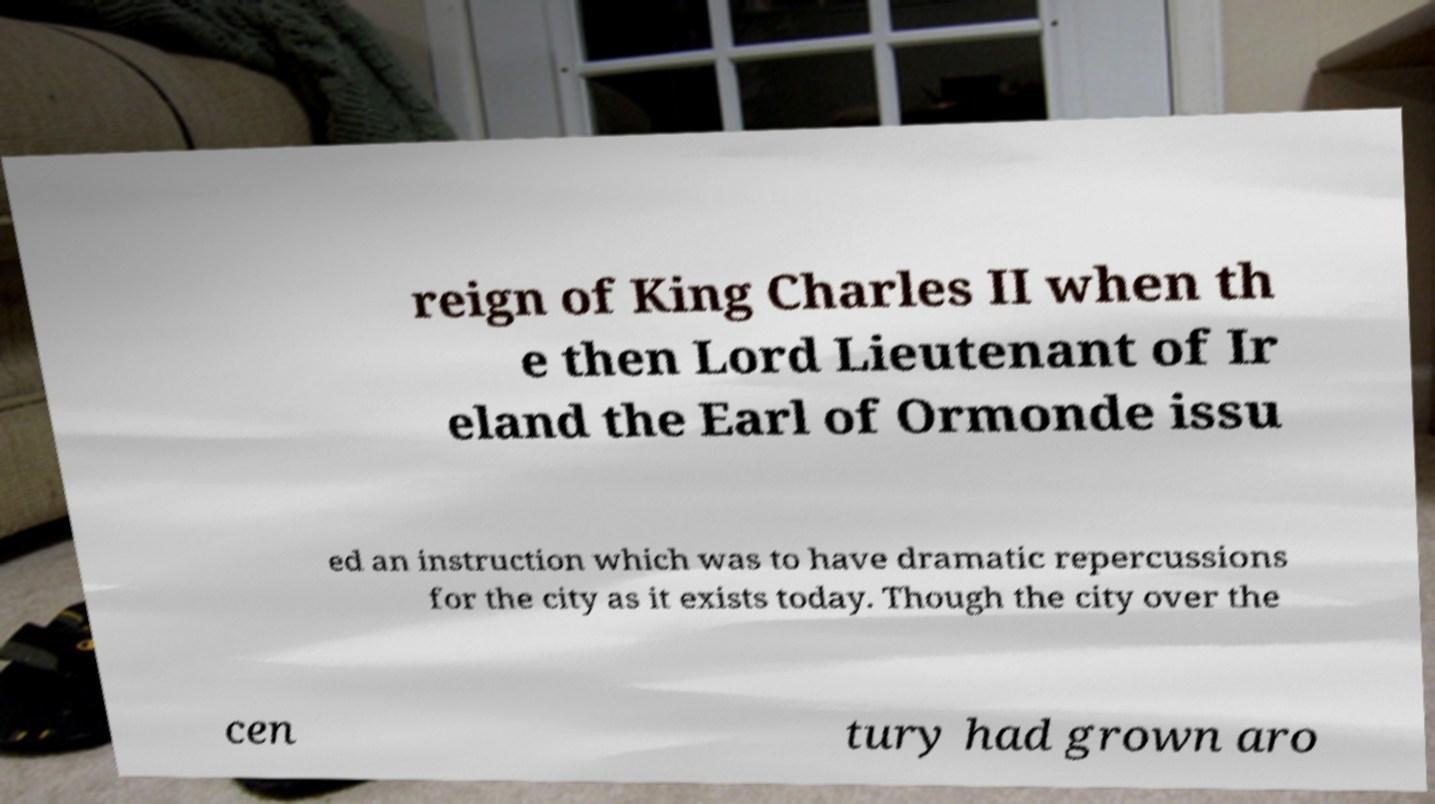Could you assist in decoding the text presented in this image and type it out clearly? reign of King Charles II when th e then Lord Lieutenant of Ir eland the Earl of Ormonde issu ed an instruction which was to have dramatic repercussions for the city as it exists today. Though the city over the cen tury had grown aro 